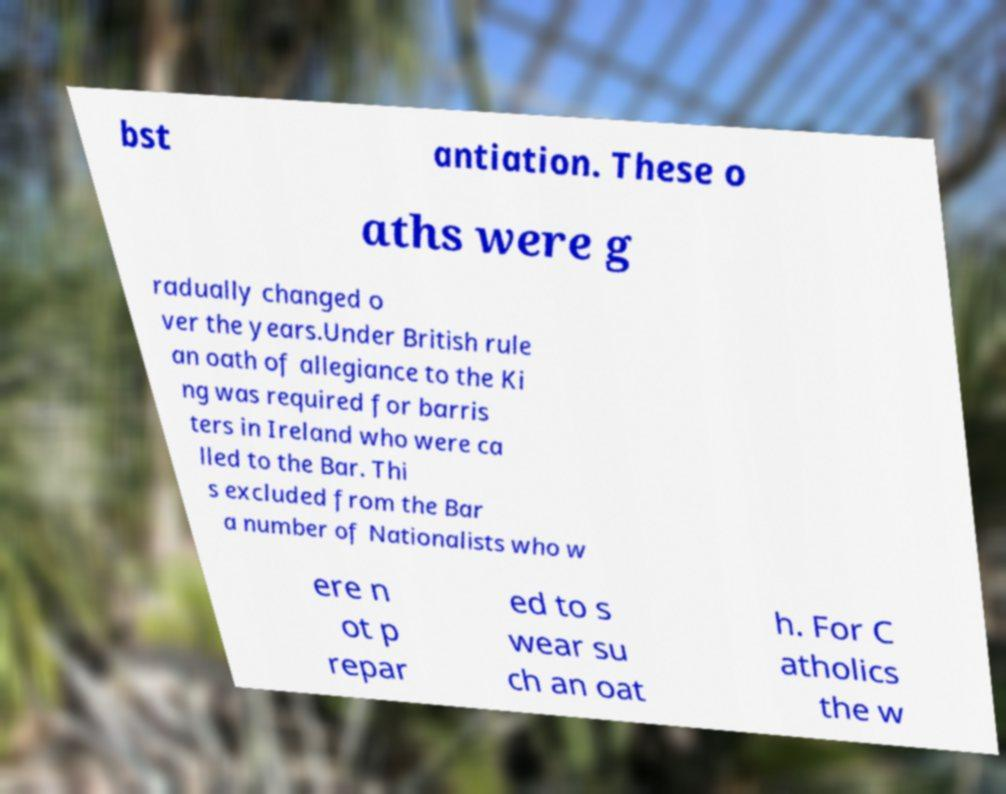For documentation purposes, I need the text within this image transcribed. Could you provide that? bst antiation. These o aths were g radually changed o ver the years.Under British rule an oath of allegiance to the Ki ng was required for barris ters in Ireland who were ca lled to the Bar. Thi s excluded from the Bar a number of Nationalists who w ere n ot p repar ed to s wear su ch an oat h. For C atholics the w 